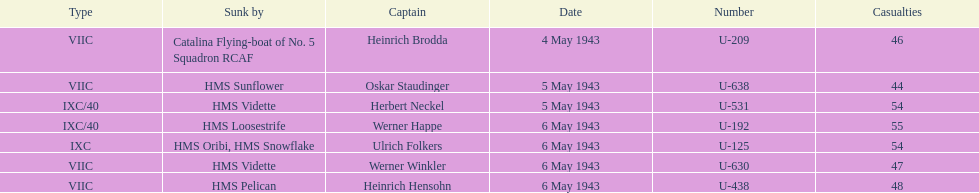Which u-boat had more than 54 casualties? U-192. 